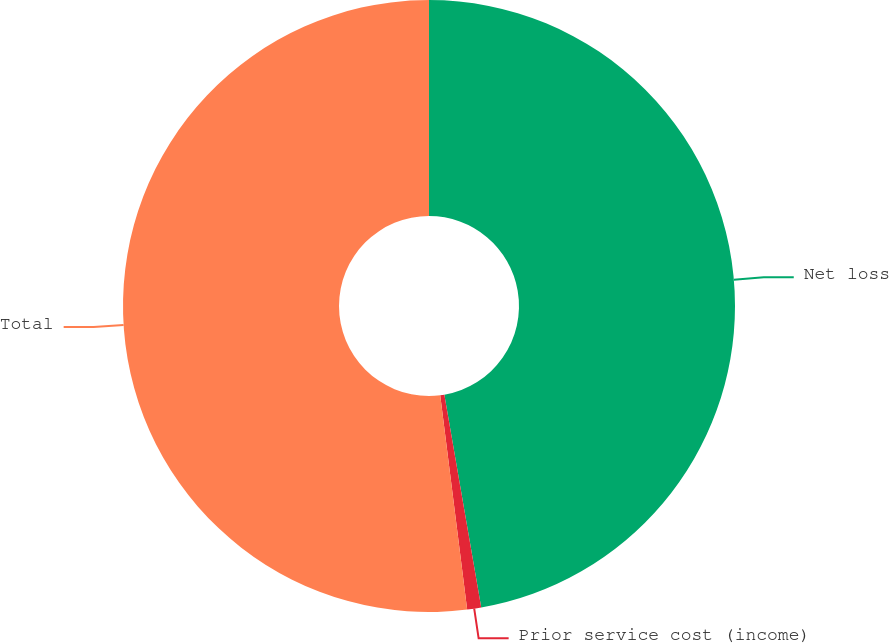Convert chart. <chart><loc_0><loc_0><loc_500><loc_500><pie_chart><fcel>Net loss<fcel>Prior service cost (income)<fcel>Total<nl><fcel>47.27%<fcel>0.74%<fcel>51.99%<nl></chart> 